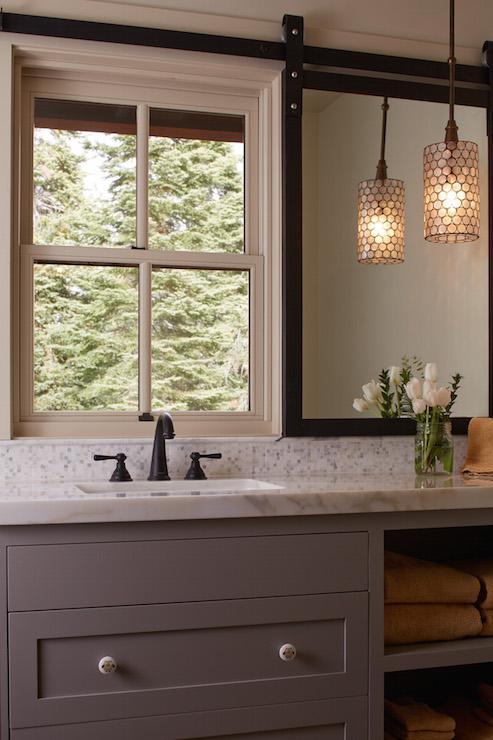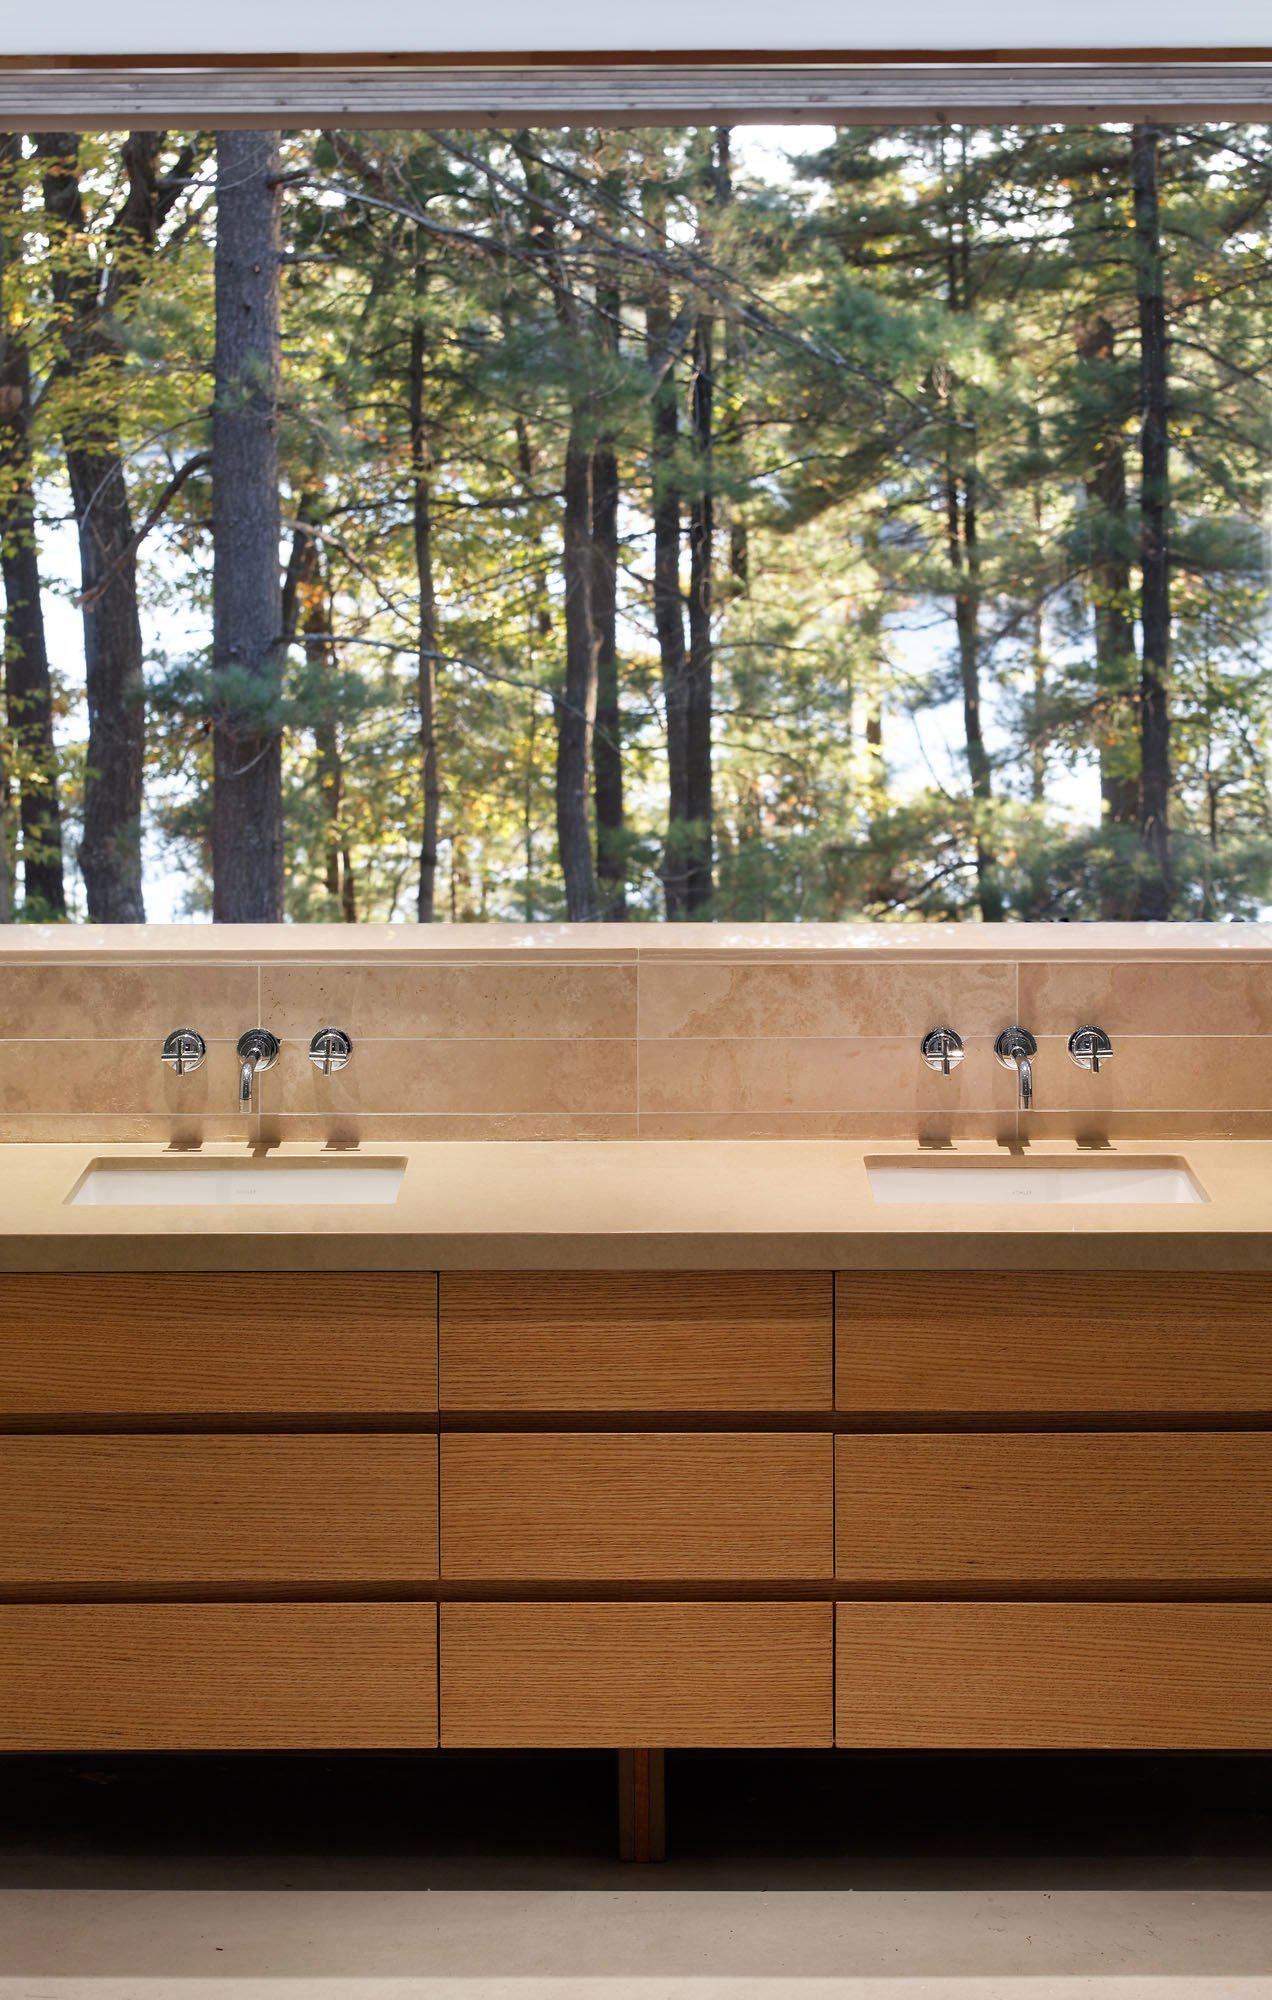The first image is the image on the left, the second image is the image on the right. Assess this claim about the two images: "In one image, a panel of the shower enclosure has a lower section that is an extension of the bathroom wall and an upper section that is a clear glass window showing the shower head.". Correct or not? Answer yes or no. No. The first image is the image on the left, the second image is the image on the right. Assess this claim about the two images: "An image shows a paned window near a sink with one spout and separate faucet handles.". Correct or not? Answer yes or no. Yes. 